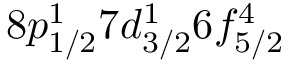<formula> <loc_0><loc_0><loc_500><loc_500>8 p _ { 1 / 2 } ^ { 1 } 7 d _ { 3 / 2 } ^ { 1 } 6 f _ { 5 / 2 } ^ { 4 }</formula> 